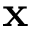Convert formula to latex. <formula><loc_0><loc_0><loc_500><loc_500>x</formula> 